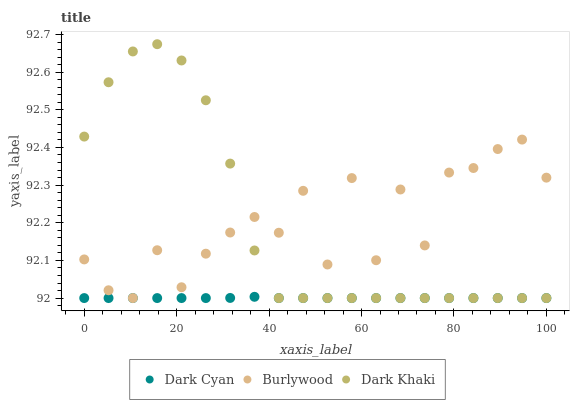Does Dark Cyan have the minimum area under the curve?
Answer yes or no. Yes. Does Burlywood have the maximum area under the curve?
Answer yes or no. Yes. Does Dark Khaki have the minimum area under the curve?
Answer yes or no. No. Does Dark Khaki have the maximum area under the curve?
Answer yes or no. No. Is Dark Cyan the smoothest?
Answer yes or no. Yes. Is Burlywood the roughest?
Answer yes or no. Yes. Is Dark Khaki the smoothest?
Answer yes or no. No. Is Dark Khaki the roughest?
Answer yes or no. No. Does Dark Cyan have the lowest value?
Answer yes or no. Yes. Does Dark Khaki have the highest value?
Answer yes or no. Yes. Does Burlywood have the highest value?
Answer yes or no. No. Does Burlywood intersect Dark Khaki?
Answer yes or no. Yes. Is Burlywood less than Dark Khaki?
Answer yes or no. No. Is Burlywood greater than Dark Khaki?
Answer yes or no. No. 